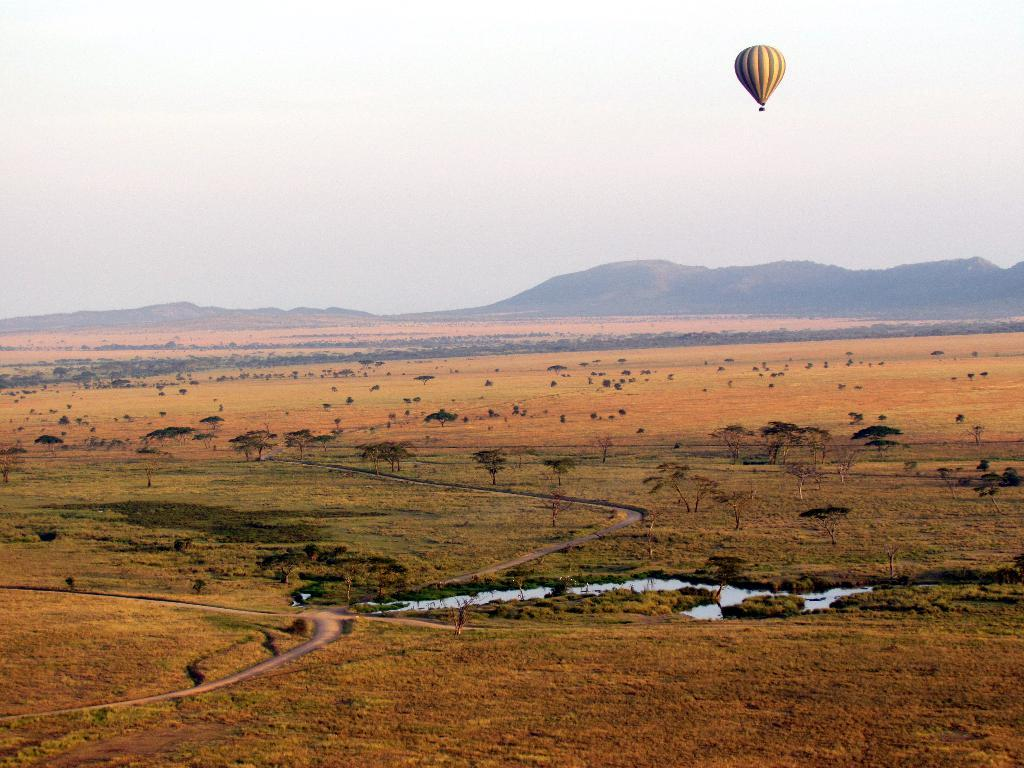What is one of the natural elements present in the image? There is water in the image. What type of vegetation can be seen in the image? There are trees in the image. What geographical feature is visible in the image? There are hills in the image. What is visible in the sky in the image? The sky is visible in the image. What man-made object can be seen in the image? There is a hot air balloon in the image. What type of calculator can be seen hanging from the trees in the image? There is no calculator present in the image, and therefore no such object can be observed hanging from the trees. 